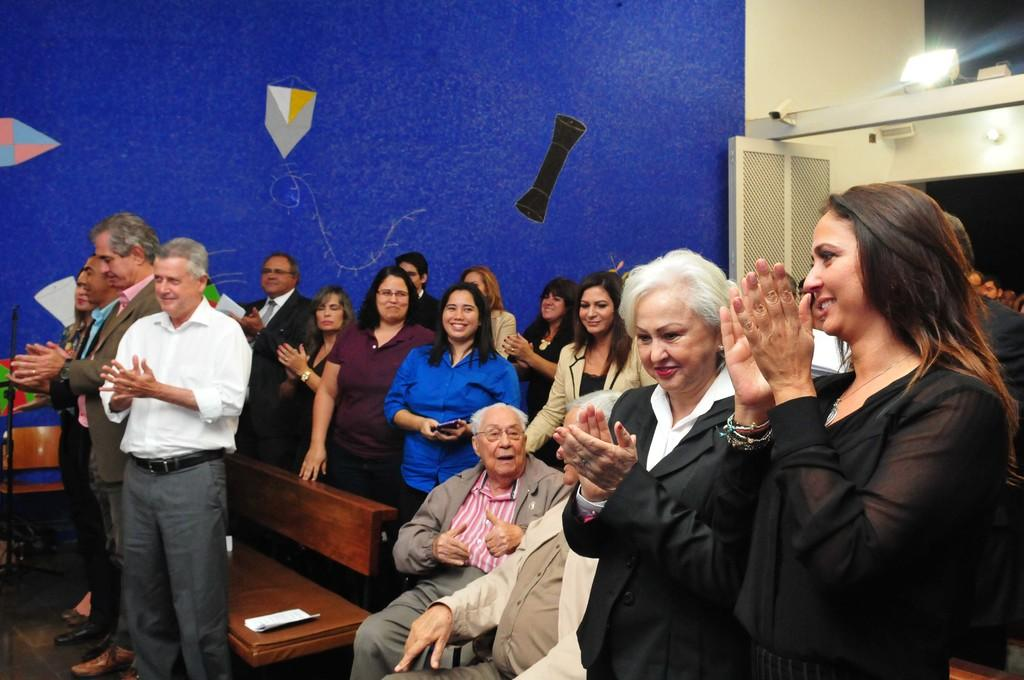How many people are in the image? There is a group of people standing in the image, and two persons are sitting, making a total of at least three people. What furniture is present in the image? There is a bench and a chair in the image. What can be seen on the wall in the image? There is a painting on the wall in the image. What type of light is visible in the image? There is a light in the image. What country's flag is being waved by the group of people in the image? There is no flag visible in the image, and the group of people is not waving any flags. What unit of measurement is being used to determine the size of the painting on the wall? The size of the painting on the wall is not mentioned in the image, and therefore, no unit of measurement can be determined. 